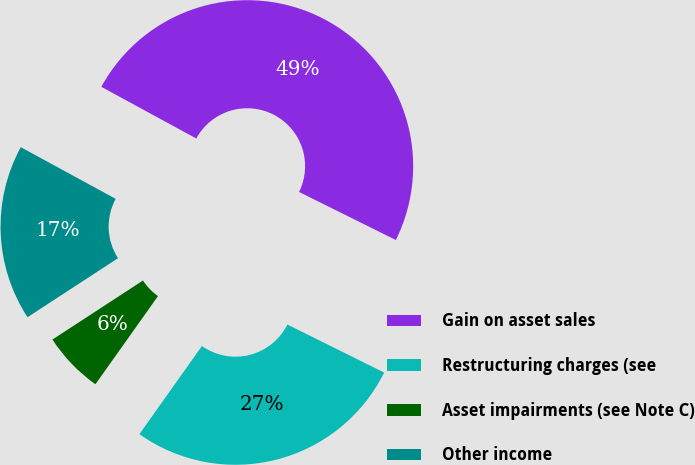Convert chart to OTSL. <chart><loc_0><loc_0><loc_500><loc_500><pie_chart><fcel>Gain on asset sales<fcel>Restructuring charges (see<fcel>Asset impairments (see Note C)<fcel>Other income<nl><fcel>49.4%<fcel>27.49%<fcel>5.98%<fcel>17.13%<nl></chart> 